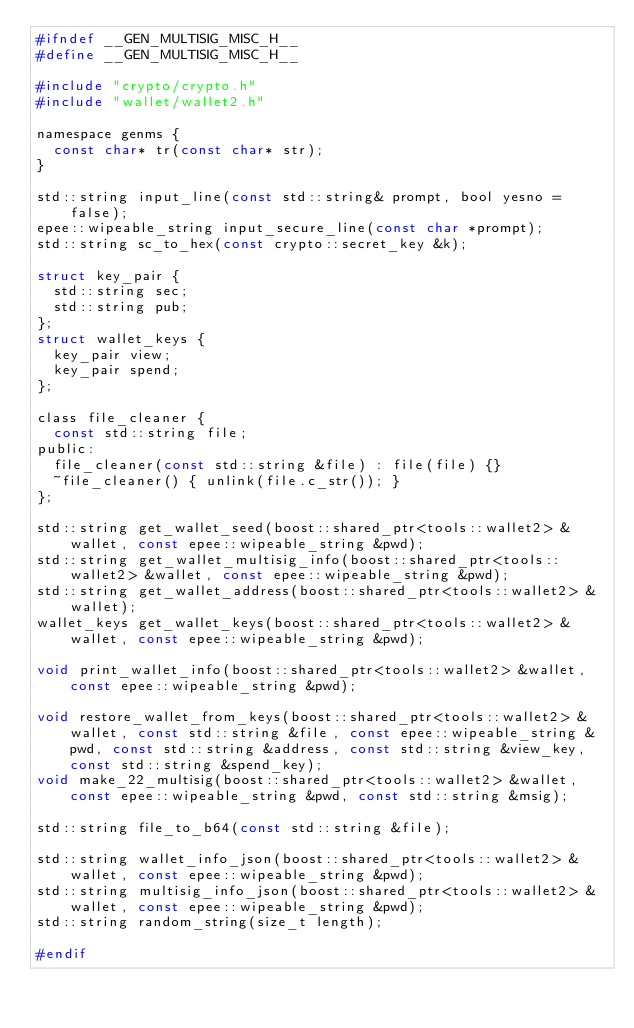<code> <loc_0><loc_0><loc_500><loc_500><_C_>#ifndef __GEN_MULTISIG_MISC_H__
#define __GEN_MULTISIG_MISC_H__

#include "crypto/crypto.h"
#include "wallet/wallet2.h"

namespace genms {
  const char* tr(const char* str);
}

std::string input_line(const std::string& prompt, bool yesno = false);
epee::wipeable_string input_secure_line(const char *prompt);
std::string sc_to_hex(const crypto::secret_key &k);

struct key_pair {
  std::string sec;
  std::string pub;
};
struct wallet_keys {
  key_pair view;
  key_pair spend;
};

class file_cleaner {
  const std::string file;
public:
  file_cleaner(const std::string &file) : file(file) {}
  ~file_cleaner() { unlink(file.c_str()); }
};

std::string get_wallet_seed(boost::shared_ptr<tools::wallet2> &wallet, const epee::wipeable_string &pwd);
std::string get_wallet_multisig_info(boost::shared_ptr<tools::wallet2> &wallet, const epee::wipeable_string &pwd);
std::string get_wallet_address(boost::shared_ptr<tools::wallet2> &wallet);
wallet_keys get_wallet_keys(boost::shared_ptr<tools::wallet2> &wallet, const epee::wipeable_string &pwd);

void print_wallet_info(boost::shared_ptr<tools::wallet2> &wallet, const epee::wipeable_string &pwd);

void restore_wallet_from_keys(boost::shared_ptr<tools::wallet2> &wallet, const std::string &file, const epee::wipeable_string &pwd, const std::string &address, const std::string &view_key, const std::string &spend_key);
void make_22_multisig(boost::shared_ptr<tools::wallet2> &wallet, const epee::wipeable_string &pwd, const std::string &msig);

std::string file_to_b64(const std::string &file);

std::string wallet_info_json(boost::shared_ptr<tools::wallet2> &wallet, const epee::wipeable_string &pwd);
std::string multisig_info_json(boost::shared_ptr<tools::wallet2> &wallet, const epee::wipeable_string &pwd);
std::string random_string(size_t length);

#endif
</code> 